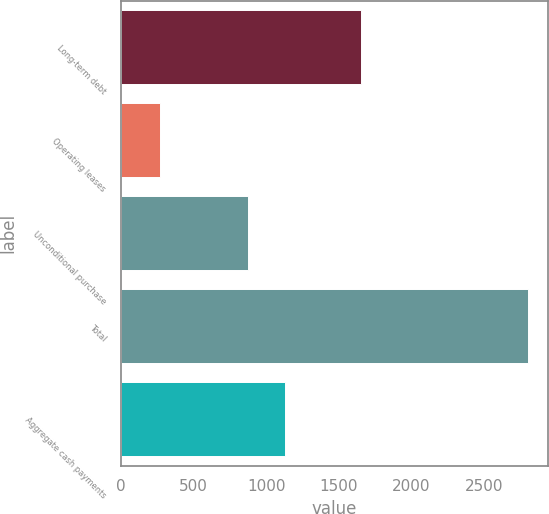Convert chart. <chart><loc_0><loc_0><loc_500><loc_500><bar_chart><fcel>Long-term debt<fcel>Operating leases<fcel>Unconditional purchase<fcel>Total<fcel>Aggregate cash payments<nl><fcel>1651<fcel>269<fcel>878<fcel>2799<fcel>1131<nl></chart> 